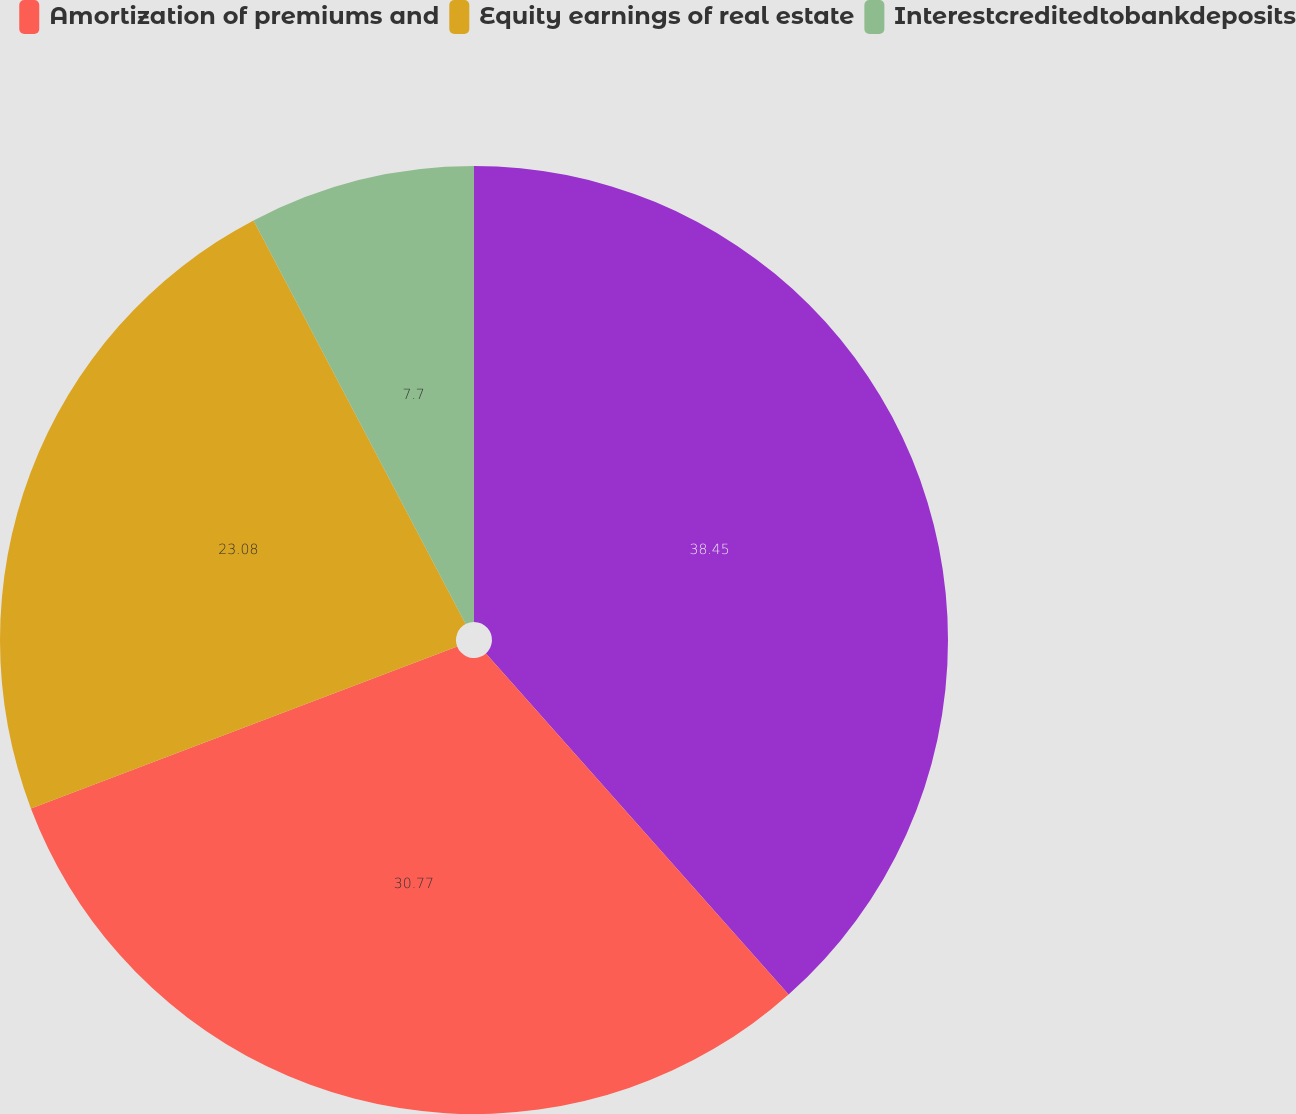Convert chart. <chart><loc_0><loc_0><loc_500><loc_500><pie_chart><ecel><fcel>Amortization of premiums and<fcel>Equity earnings of real estate<fcel>Interestcreditedtobankdeposits<nl><fcel>38.45%<fcel>30.77%<fcel>23.08%<fcel>7.7%<nl></chart> 